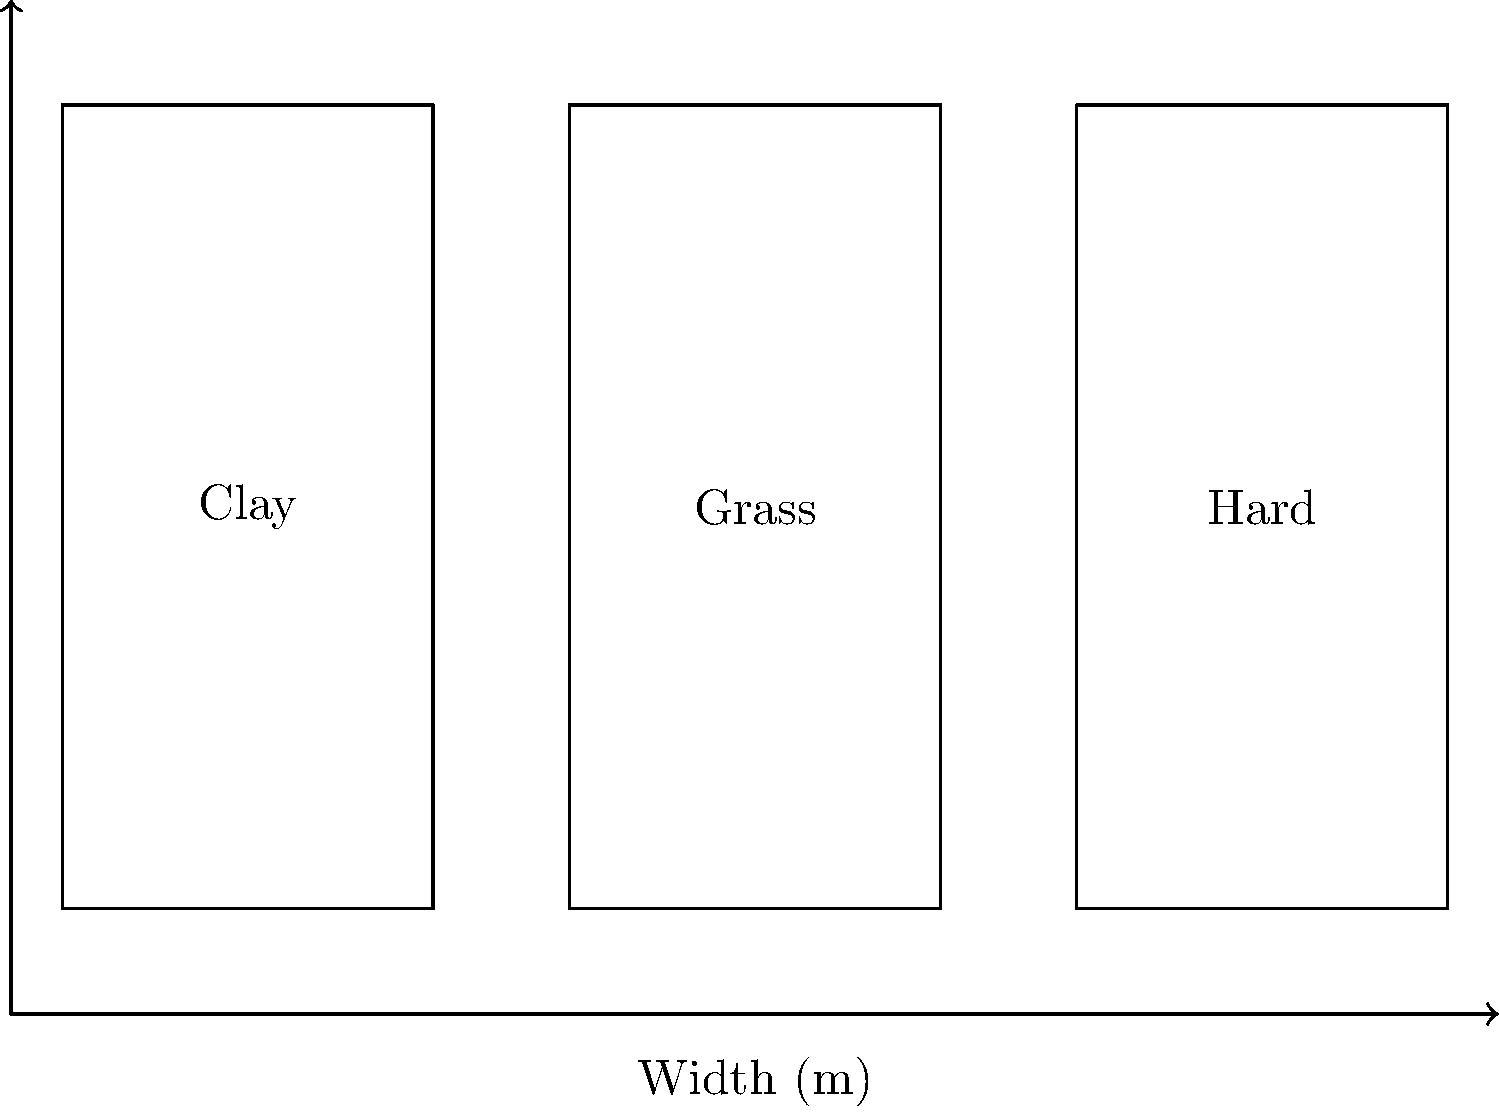Based on the diagram comparing tennis court dimensions, what is the area difference between a clay court and a grass court? To solve this problem, let's follow these steps:

1. Observe that all court types have the same dimensions:
   Width = 10.97 m
   Length = 23.77 m

2. Calculate the area of a single court:
   Area = Width × Length
   Area = 10.97 m × 23.77 m = 260.7569 m²

3. Compare the areas of clay and grass courts:
   Clay court area = 260.7569 m²
   Grass court area = 260.7569 m²

4. Calculate the difference:
   Area difference = Clay court area - Grass court area
   Area difference = 260.7569 m² - 260.7569 m² = 0 m²

Therefore, there is no difference in area between a clay court and a grass court.
Answer: 0 m² 